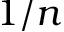<formula> <loc_0><loc_0><loc_500><loc_500>1 / n</formula> 